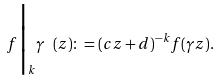<formula> <loc_0><loc_0><loc_500><loc_500>f \Big | _ { k } \gamma \ ( z ) \colon = ( c z + d ) ^ { - k } f ( \gamma z ) .</formula> 